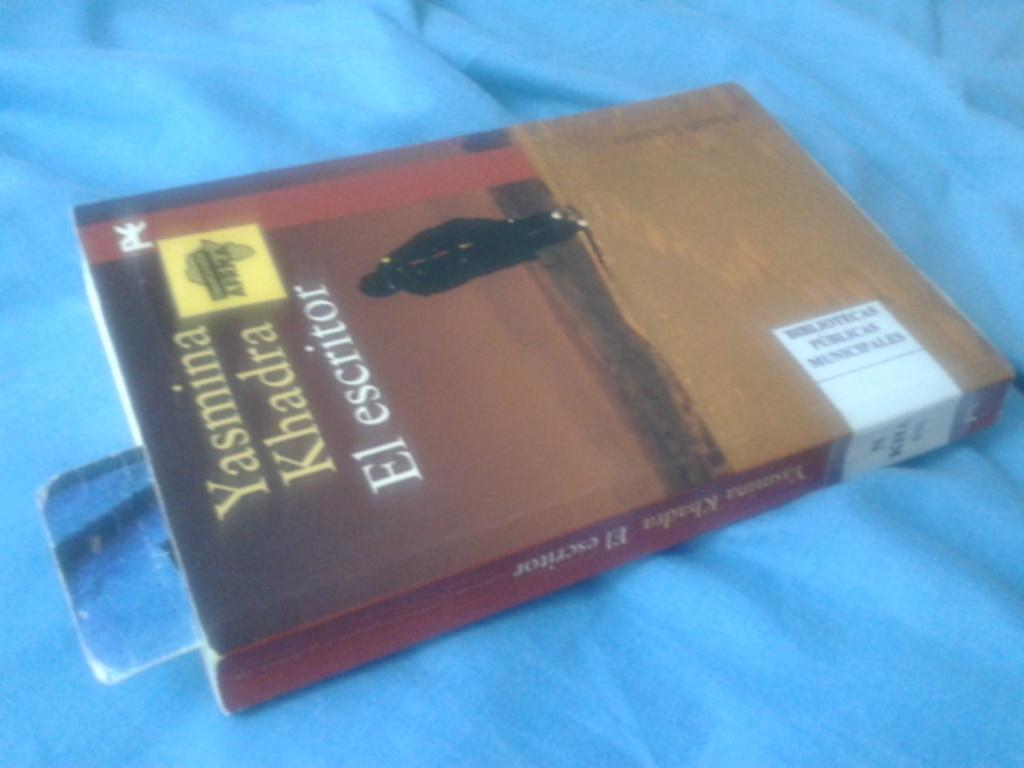<image>
Summarize the visual content of the image. Yasmina Khadra wrote the book El escritor which appears to be a library book.. 